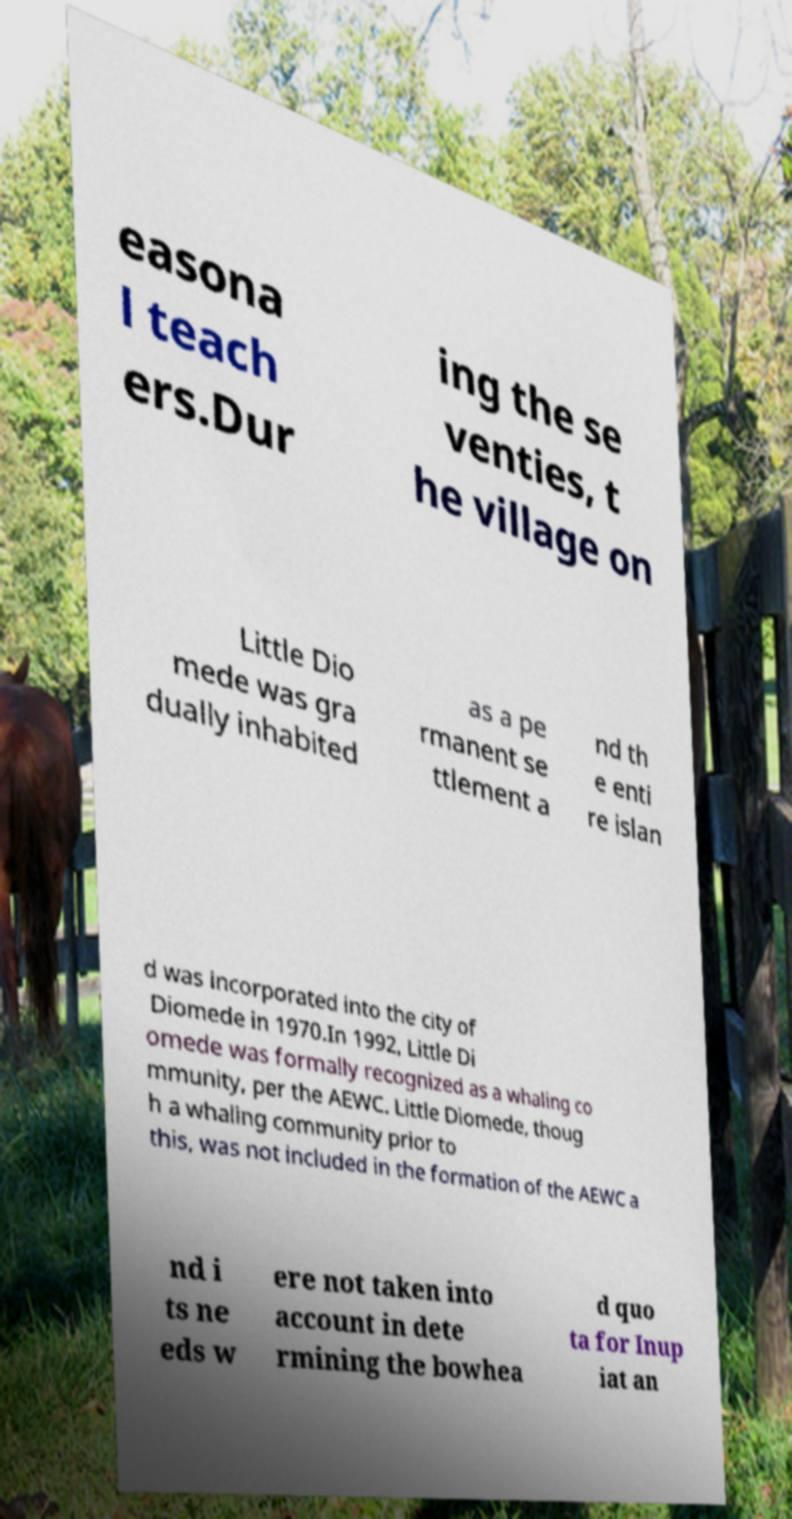Could you extract and type out the text from this image? easona l teach ers.Dur ing the se venties, t he village on Little Dio mede was gra dually inhabited as a pe rmanent se ttlement a nd th e enti re islan d was incorporated into the city of Diomede in 1970.In 1992, Little Di omede was formally recognized as a whaling co mmunity, per the AEWC. Little Diomede, thoug h a whaling community prior to this, was not included in the formation of the AEWC a nd i ts ne eds w ere not taken into account in dete rmining the bowhea d quo ta for Inup iat an 